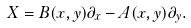Convert formula to latex. <formula><loc_0><loc_0><loc_500><loc_500>X = B ( x , y ) \partial _ { x } - A ( x , y ) \partial _ { y } .</formula> 